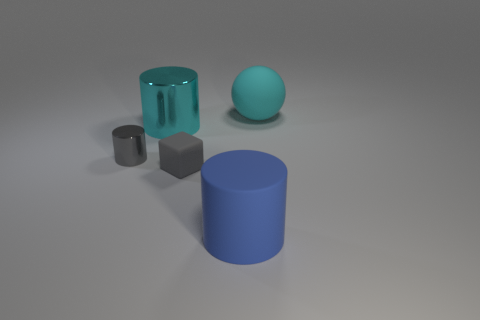Is there any other thing that is the same size as the rubber cube?
Your answer should be very brief. Yes. What number of things are rubber objects or things to the left of the tiny gray rubber cube?
Your response must be concise. 5. Do the cyan object that is to the right of the big metal cylinder and the cyan thing that is in front of the rubber ball have the same size?
Provide a succinct answer. Yes. How many other things are the same color as the matte cylinder?
Offer a very short reply. 0. There is a matte block; is its size the same as the cyan thing on the left side of the sphere?
Your answer should be compact. No. There is a cyan object left of the large matte thing to the right of the large blue rubber cylinder; how big is it?
Give a very brief answer. Large. There is a big metallic object that is the same shape as the small metal object; what color is it?
Offer a very short reply. Cyan. Is the rubber ball the same size as the blue cylinder?
Your answer should be compact. Yes. Is the number of cyan matte things in front of the large shiny cylinder the same as the number of gray blocks?
Provide a short and direct response. No. There is a small gray object that is in front of the gray metal thing; is there a cube in front of it?
Your answer should be very brief. No. 